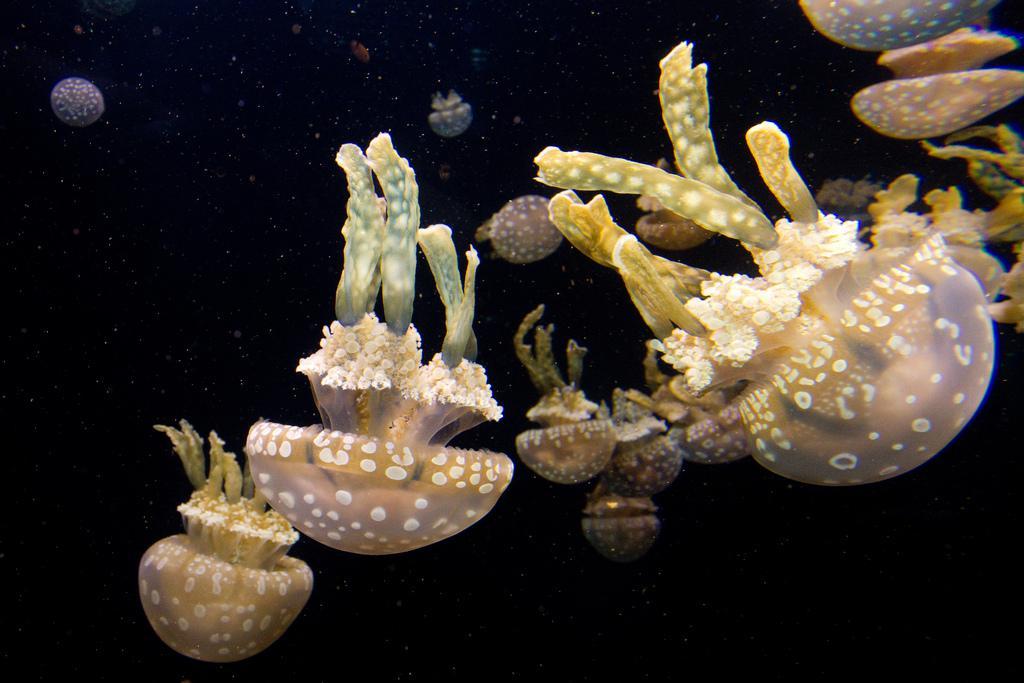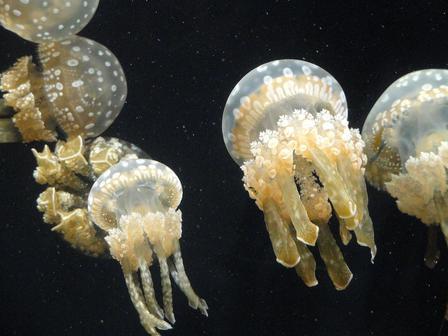The first image is the image on the left, the second image is the image on the right. Examine the images to the left and right. Is the description "Right and left images each show the same neutral-colored type of jellyfish." accurate? Answer yes or no. Yes. The first image is the image on the left, the second image is the image on the right. Given the left and right images, does the statement "The right image has fewer than four jellyfish." hold true? Answer yes or no. No. 